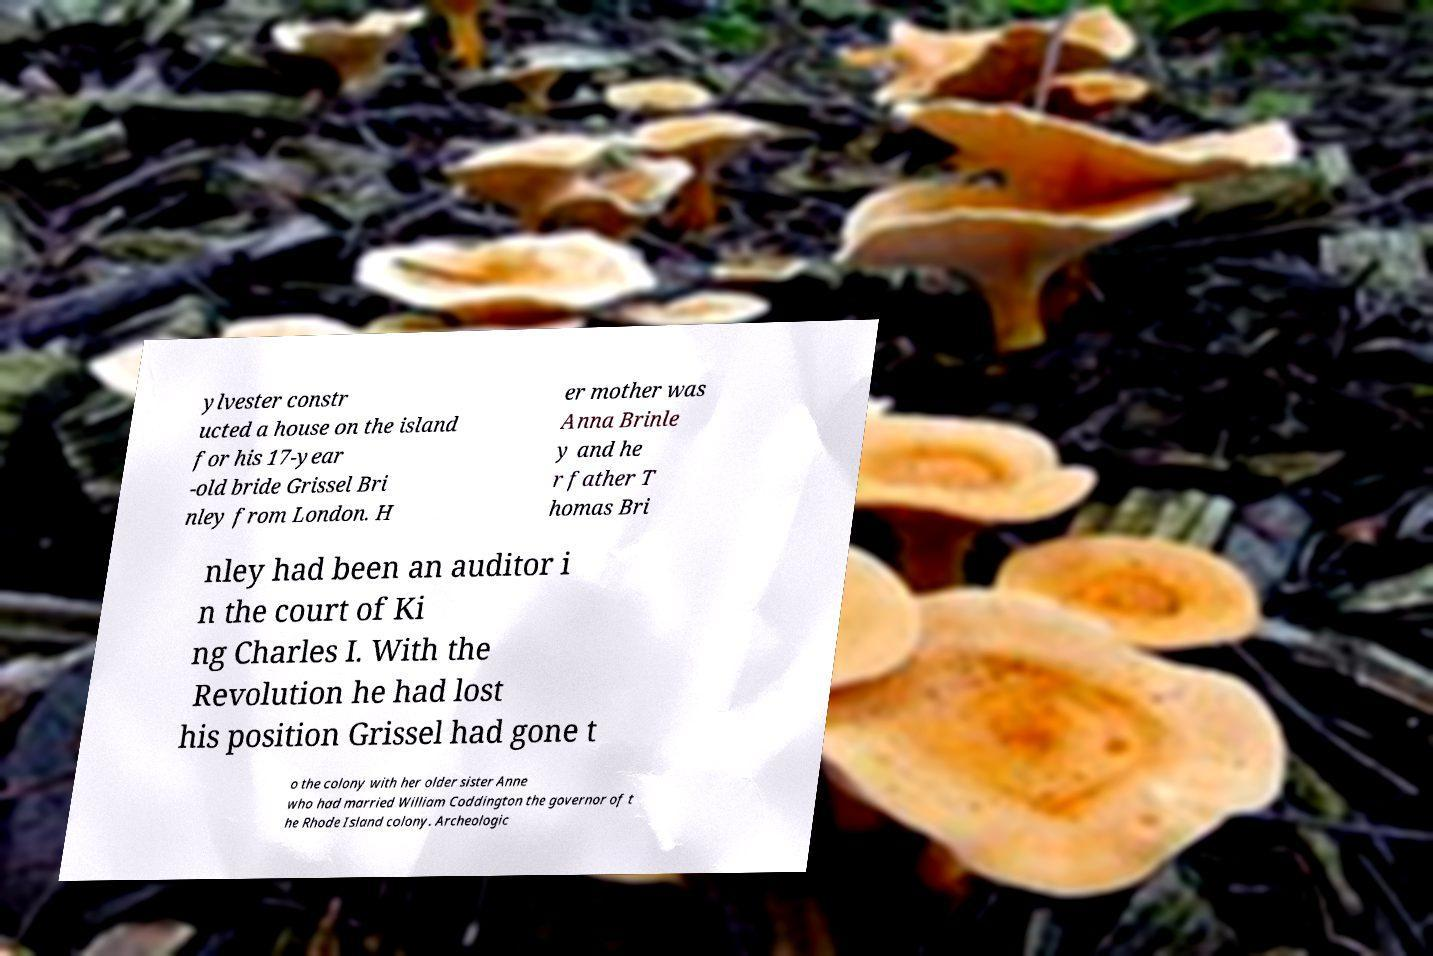What messages or text are displayed in this image? I need them in a readable, typed format. ylvester constr ucted a house on the island for his 17-year -old bride Grissel Bri nley from London. H er mother was Anna Brinle y and he r father T homas Bri nley had been an auditor i n the court of Ki ng Charles I. With the Revolution he had lost his position Grissel had gone t o the colony with her older sister Anne who had married William Coddington the governor of t he Rhode Island colony. Archeologic 